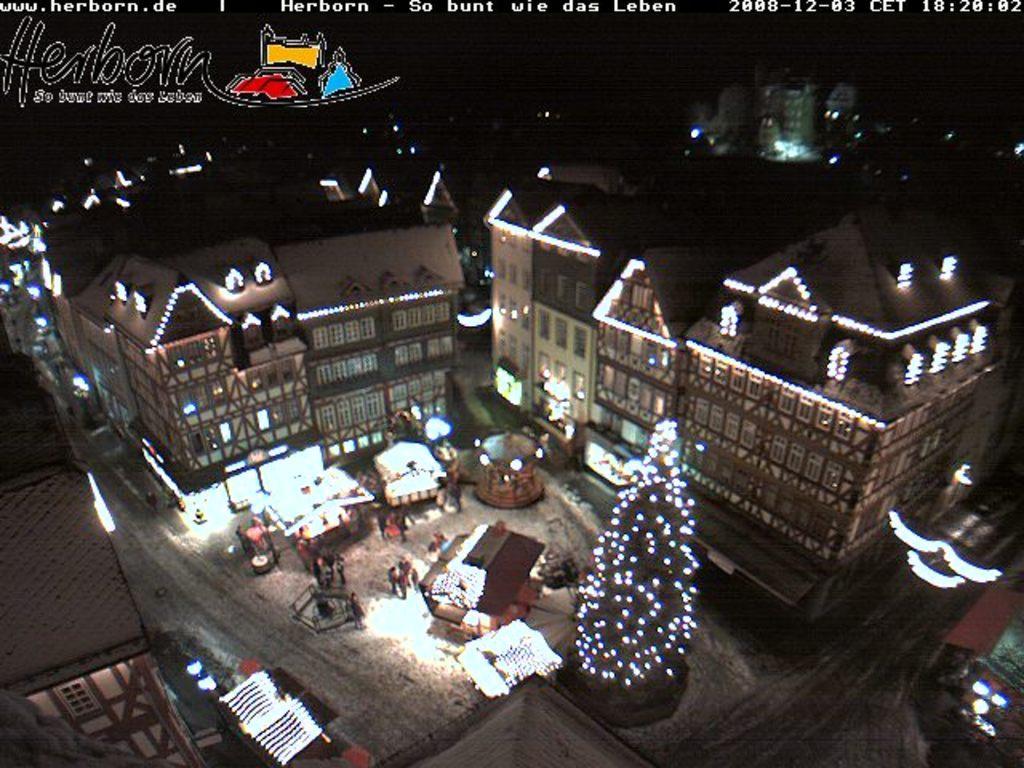In one or two sentences, can you explain what this image depicts? In this picture there are buildings around the area of the image, which are decorated with lights and there is a decorated tree in the image, it seems to be the picture is captured during night time. 